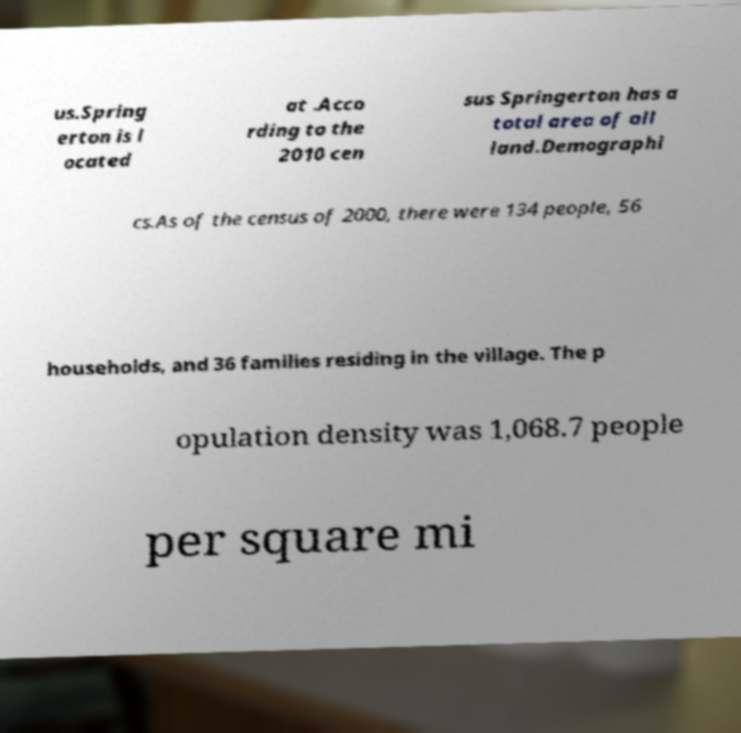What messages or text are displayed in this image? I need them in a readable, typed format. us.Spring erton is l ocated at .Acco rding to the 2010 cen sus Springerton has a total area of all land.Demographi cs.As of the census of 2000, there were 134 people, 56 households, and 36 families residing in the village. The p opulation density was 1,068.7 people per square mi 